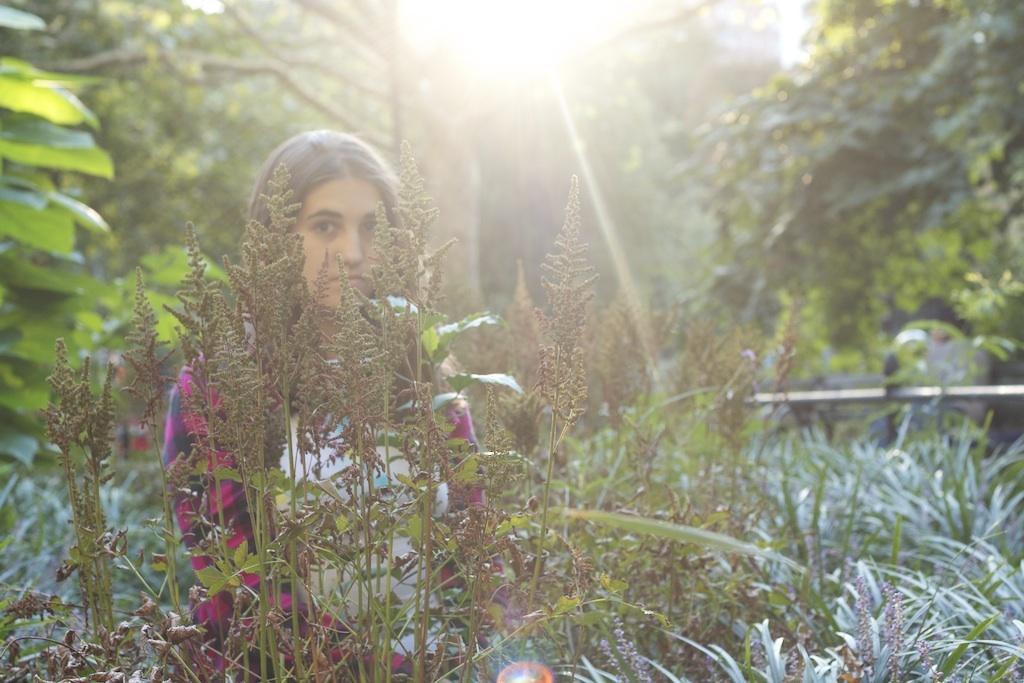Can you describe this image briefly? In the center of the image we can see a lady standing. At the bottom there are plants and grass. In the background there are trees. 